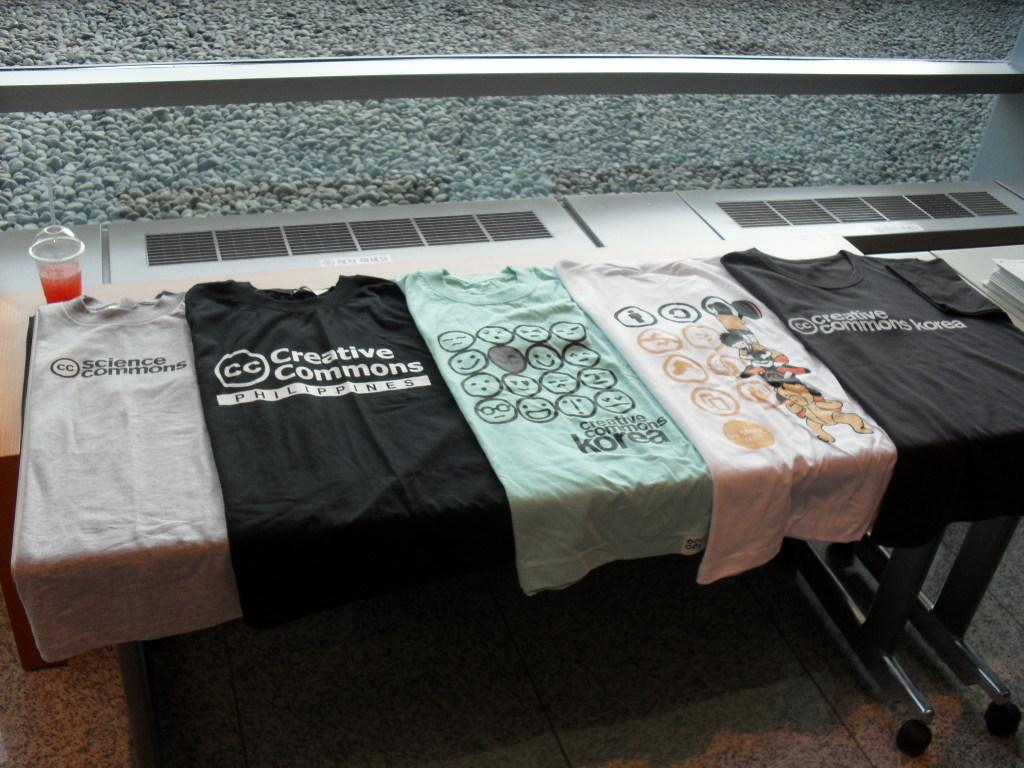What is placed on the table in the image? There are clothes arranged on a table in the image. What else can be seen in the image besides the clothes? There is a drink in the image. What type of surface is visible in the background of the image? There is a surface of rocks in the background of the image. How many giants are visible in the image? There are no giants present in the image. What type of shoe can be seen on the rocks in the image? There is no shoe visible on the rocks in the image. 